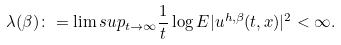Convert formula to latex. <formula><loc_0><loc_0><loc_500><loc_500>\lambda ( \beta ) \colon = \lim s u p _ { t \to \infty } \frac { 1 } { t } \log E | u ^ { h , \beta } ( t , x ) | ^ { 2 } < \infty .</formula> 